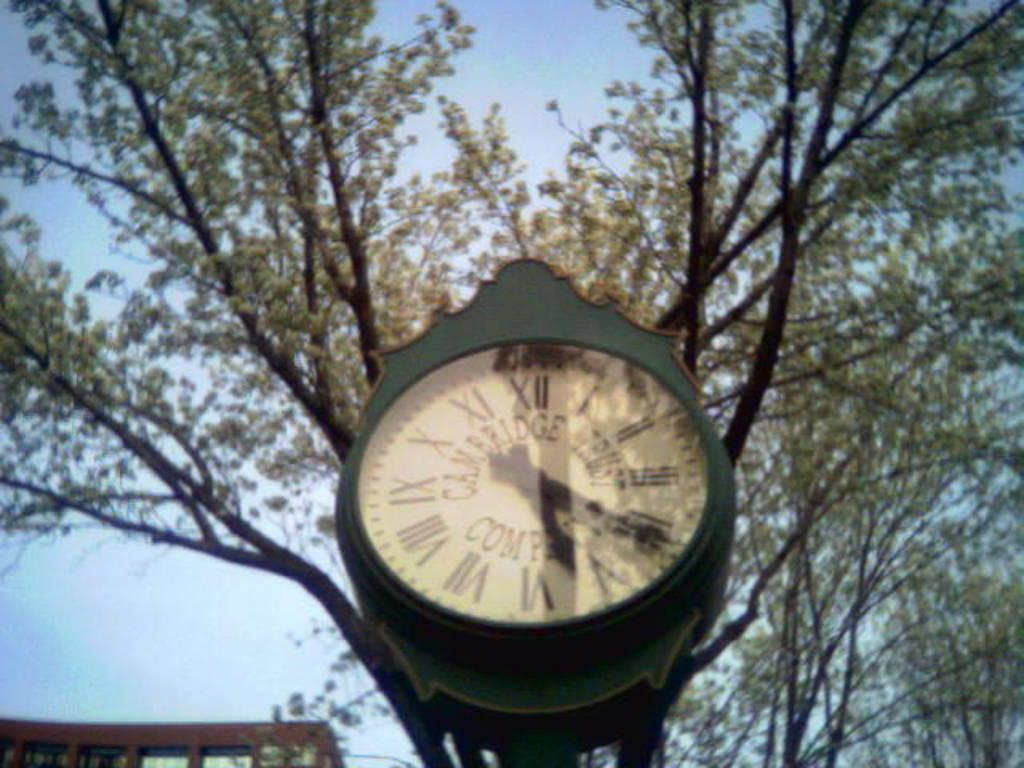<image>
Write a terse but informative summary of the picture. A green clock that says Cambridge Trust Company. 